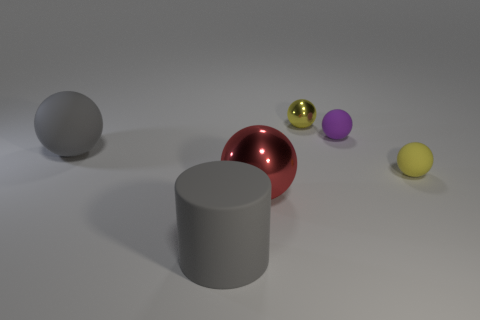Subtract all metal balls. How many balls are left? 3 Add 3 big rubber objects. How many objects exist? 9 Subtract all balls. How many objects are left? 1 Subtract all green cylinders. Subtract all brown balls. How many cylinders are left? 1 Subtract all red spheres. How many blue cylinders are left? 0 Subtract all green balls. Subtract all tiny yellow shiny objects. How many objects are left? 5 Add 3 tiny yellow spheres. How many tiny yellow spheres are left? 5 Add 1 small green balls. How many small green balls exist? 1 Subtract all yellow spheres. How many spheres are left? 3 Subtract 0 brown spheres. How many objects are left? 6 